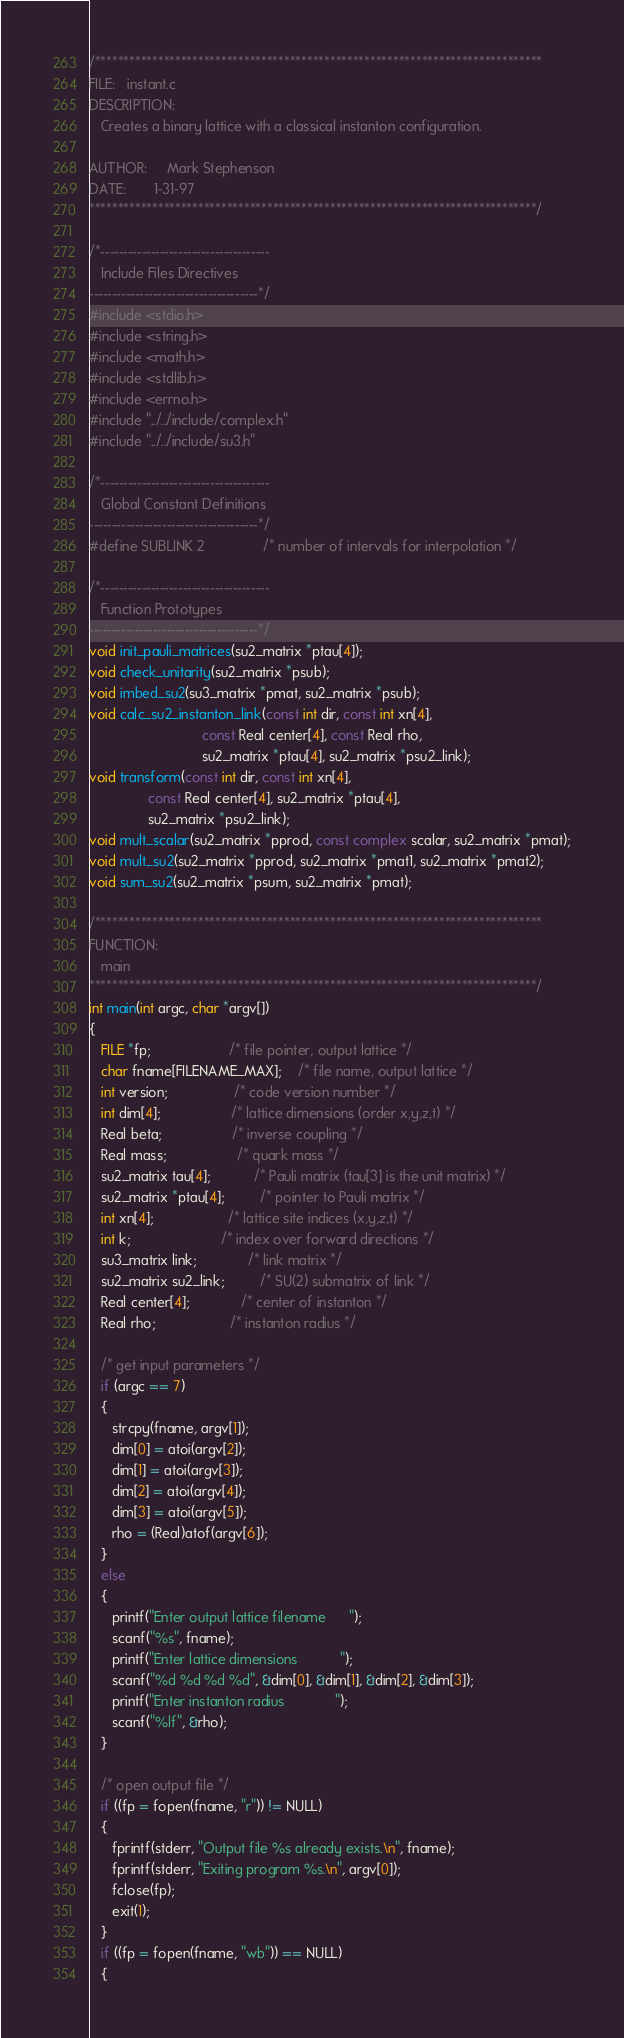<code> <loc_0><loc_0><loc_500><loc_500><_C_>/******************************************************************************
FILE:   instant.c
DESCRIPTION:
   Creates a binary lattice with a classical instanton configuration.

AUTHOR:     Mark Stephenson
DATE:       1-31-97
******************************************************************************/

/*-------------------------------------
   Include Files Directives
-------------------------------------*/
#include <stdio.h>
#include <string.h>
#include <math.h>
#include <stdlib.h>
#include <errno.h>
#include "../../include/complex.h"
#include "../../include/su3.h"

/*-------------------------------------
   Global Constant Definitions
-------------------------------------*/
#define SUBLINK 2               /* number of intervals for interpolation */

/*-------------------------------------
   Function Prototypes
-------------------------------------*/
void init_pauli_matrices(su2_matrix *ptau[4]);
void check_unitarity(su2_matrix *psub);
void imbed_su2(su3_matrix *pmat, su2_matrix *psub);
void calc_su2_instanton_link(const int dir, const int xn[4],
                             const Real center[4], const Real rho,
                             su2_matrix *ptau[4], su2_matrix *psu2_link);
void transform(const int dir, const int xn[4],
               const Real center[4], su2_matrix *ptau[4],
               su2_matrix *psu2_link);
void mult_scalar(su2_matrix *pprod, const complex scalar, su2_matrix *pmat);
void mult_su2(su2_matrix *pprod, su2_matrix *pmat1, su2_matrix *pmat2);
void sum_su2(su2_matrix *psum, su2_matrix *pmat);

/******************************************************************************
FUNCTION:
   main
******************************************************************************/
int main(int argc, char *argv[])
{
   FILE *fp;                    /* file pointer, output lattice */
   char fname[FILENAME_MAX];    /* file name, output lattice */
   int version;                 /* code version number */
   int dim[4];                  /* lattice dimensions (order x,y,z,t) */
   Real beta;                  /* inverse coupling */
   Real mass;                  /* quark mass */
   su2_matrix tau[4];           /* Pauli matrix (tau[3] is the unit matrix) */
   su2_matrix *ptau[4];         /* pointer to Pauli matrix */
   int xn[4];                   /* lattice site indices (x,y,z,t) */
   int k;                       /* index over forward directions */
   su3_matrix link;             /* link matrix */
   su2_matrix su2_link;         /* SU(2) submatrix of link */
   Real center[4];             /* center of instanton */
   Real rho;                   /* instanton radius */

   /* get input parameters */
   if (argc == 7)
   {
      strcpy(fname, argv[1]);
      dim[0] = atoi(argv[2]);
      dim[1] = atoi(argv[3]);
      dim[2] = atoi(argv[4]);
      dim[3] = atoi(argv[5]);
      rho = (Real)atof(argv[6]);
   }
   else
   {
      printf("Enter output lattice filename      ");
      scanf("%s", fname);
      printf("Enter lattice dimensions           ");
      scanf("%d %d %d %d", &dim[0], &dim[1], &dim[2], &dim[3]);
      printf("Enter instanton radius             ");
      scanf("%lf", &rho);
   }

   /* open output file */
   if ((fp = fopen(fname, "r")) != NULL)
   {
      fprintf(stderr, "Output file %s already exists.\n", fname);
      fprintf(stderr, "Exiting program %s.\n", argv[0]);
      fclose(fp);
      exit(1);
   }
   if ((fp = fopen(fname, "wb")) == NULL)
   {</code> 